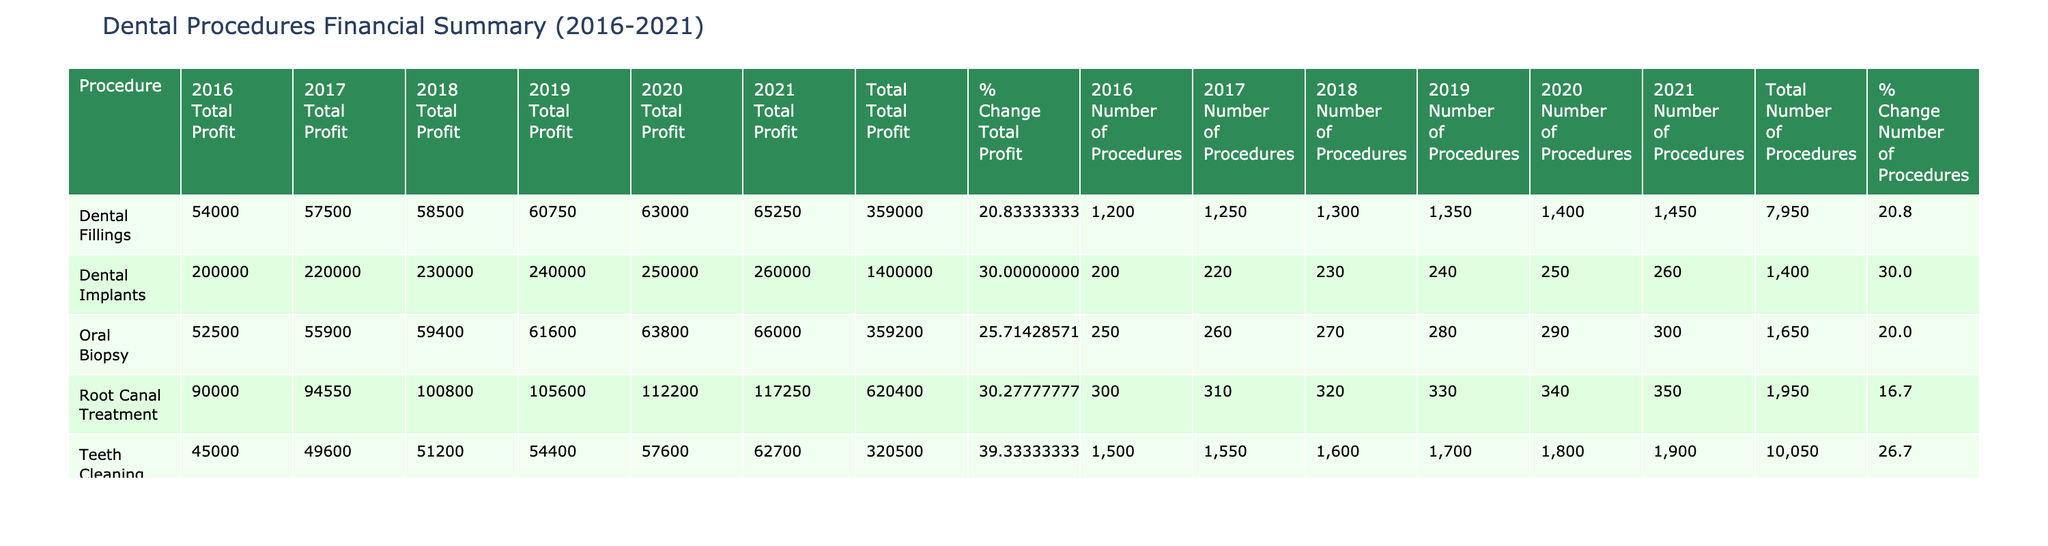What was the total profit from Dental Fillings in 2019? To find the total profit from Dental Fillings in 2019, we look at the table and find the value for '2019 Total Profit' corresponding to Dental Fillings, which is 60,750.
Answer: 60,750 Which procedure had the highest total profit in 2021? In the table, we examine the '2021 Total Profit' column for each procedure. The highest value in that column corresponds to Root Canal Treatment, which is 117,250.
Answer: Root Canal Treatment What was the percentage change in the number of procedures for Dental Implants from 2016 to 2021? We find the number of procedures for Dental Implants in 2016 (200) and in 2021 (260). The percentage change is calculated as ((260 - 200) / 200) * 100 = 30%.
Answer: 30% Did the profit margin for Oral Biopsy remain constant over the years? By checking the 'Profit Margin ($)' row for Oral Biopsy across the years, we see the values are 210, 215, 220, 220, and 220. Since these values changed in the earlier years and then remained the same in the last three years, the answer is no.
Answer: No What is the average total profit for all procedures across the 5 years (2016-2021)? We first calculate the total profit for each year by summing the 'Total Profit' values across all procedures, obtaining values of 2,680,000 (2016), 2,700,000 (2017), 2,800,000 (2018), 2,900,000 (2019), and 3,030,000 (2020; 2021). The total is 14,110,000. We then divide this by 5 years to find the average, which is 2,822,000.
Answer: 2,822,000 Which procedure saw the largest increase in total profit from 2016 to 2021? First, we note the total profits for each procedure in 2016 and 2021: Teeth Cleaning (45,000 to 62,700), Dental Fillings (54,000 to 65,000), Root Canal Treatment (90,000 to 117,750), Dental Implants (200,000 to 260,000), and Oral Biopsy (52,500 to 76,800). The largest increase is for Dental Implants, which went from 200,000 to 260,000, gaining 60,000.
Answer: Dental Implants 